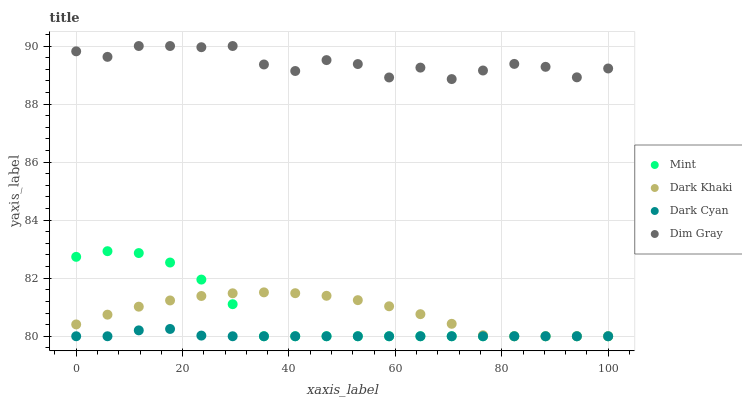Does Dark Cyan have the minimum area under the curve?
Answer yes or no. Yes. Does Dim Gray have the maximum area under the curve?
Answer yes or no. Yes. Does Dim Gray have the minimum area under the curve?
Answer yes or no. No. Does Dark Cyan have the maximum area under the curve?
Answer yes or no. No. Is Dark Cyan the smoothest?
Answer yes or no. Yes. Is Dim Gray the roughest?
Answer yes or no. Yes. Is Dim Gray the smoothest?
Answer yes or no. No. Is Dark Cyan the roughest?
Answer yes or no. No. Does Dark Khaki have the lowest value?
Answer yes or no. Yes. Does Dim Gray have the lowest value?
Answer yes or no. No. Does Dim Gray have the highest value?
Answer yes or no. Yes. Does Dark Cyan have the highest value?
Answer yes or no. No. Is Dark Khaki less than Dim Gray?
Answer yes or no. Yes. Is Dim Gray greater than Dark Cyan?
Answer yes or no. Yes. Does Mint intersect Dark Khaki?
Answer yes or no. Yes. Is Mint less than Dark Khaki?
Answer yes or no. No. Is Mint greater than Dark Khaki?
Answer yes or no. No. Does Dark Khaki intersect Dim Gray?
Answer yes or no. No. 